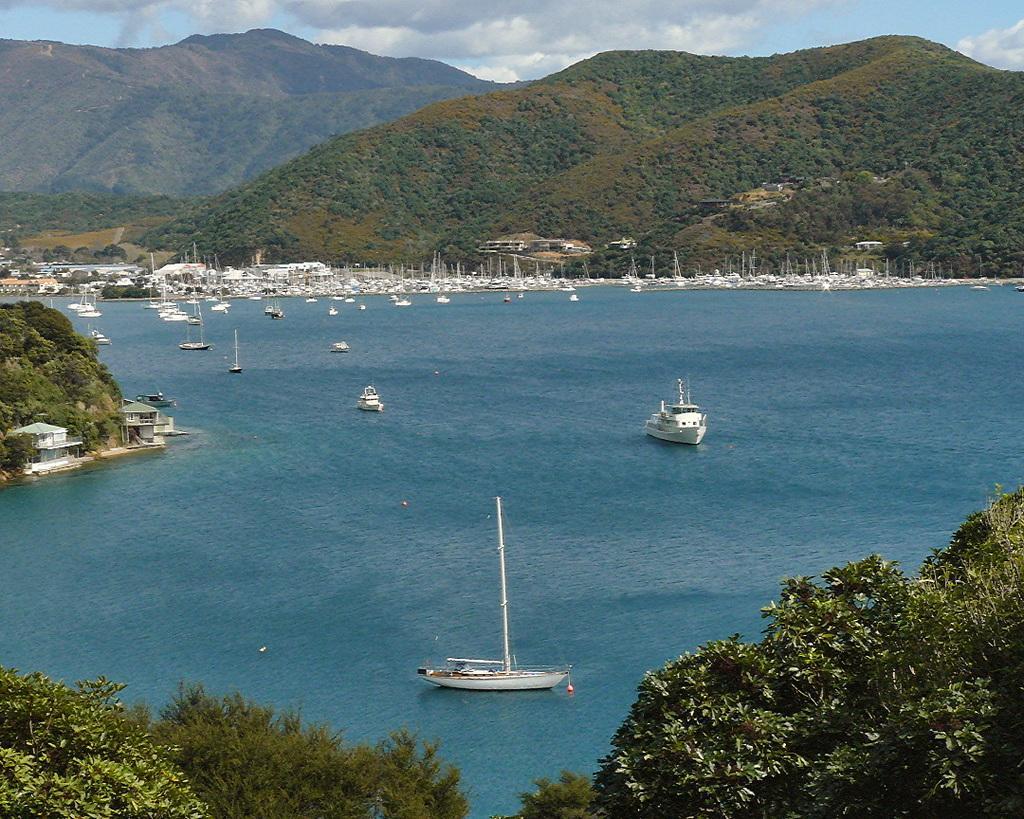Describe this image in one or two sentences. In this image I can see few boats on the water. The boats are in white color, background I can see trees in green color and the sky is in white and blue color. 